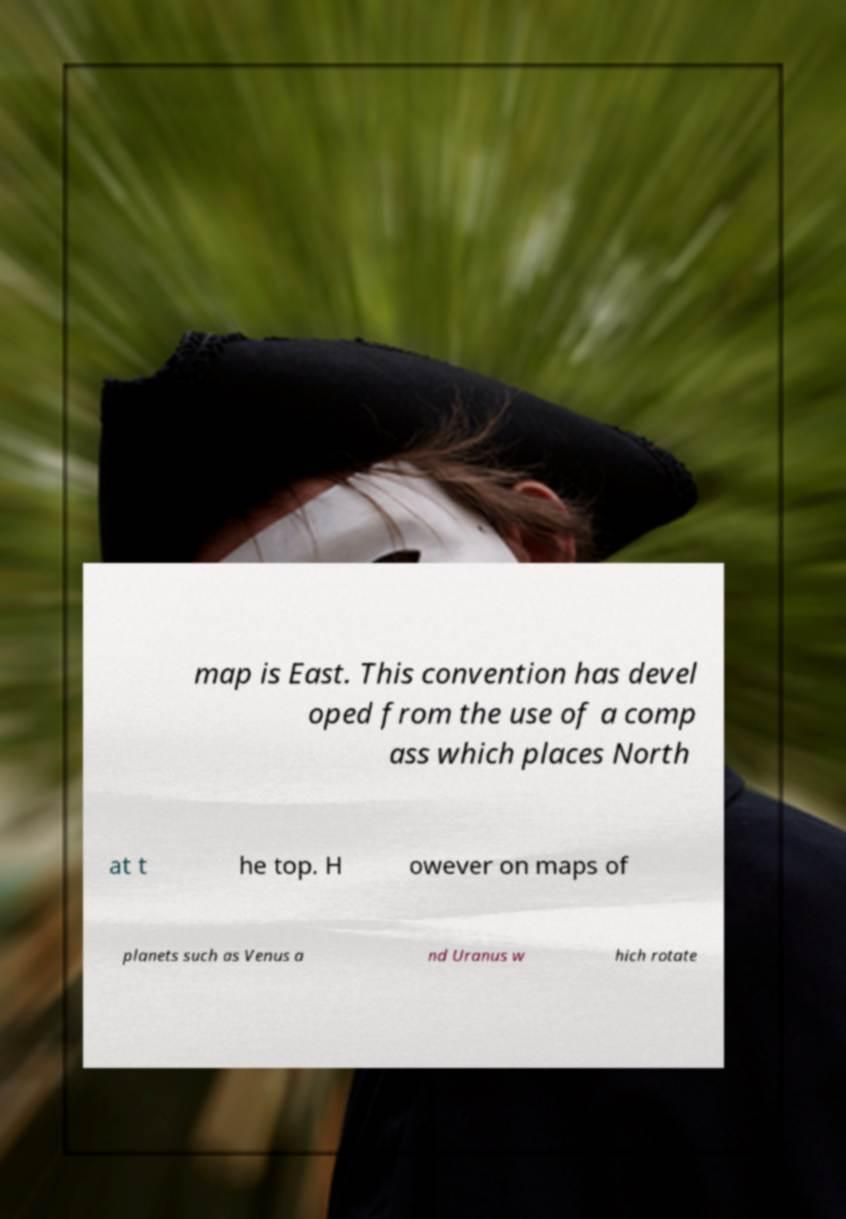Can you accurately transcribe the text from the provided image for me? map is East. This convention has devel oped from the use of a comp ass which places North at t he top. H owever on maps of planets such as Venus a nd Uranus w hich rotate 